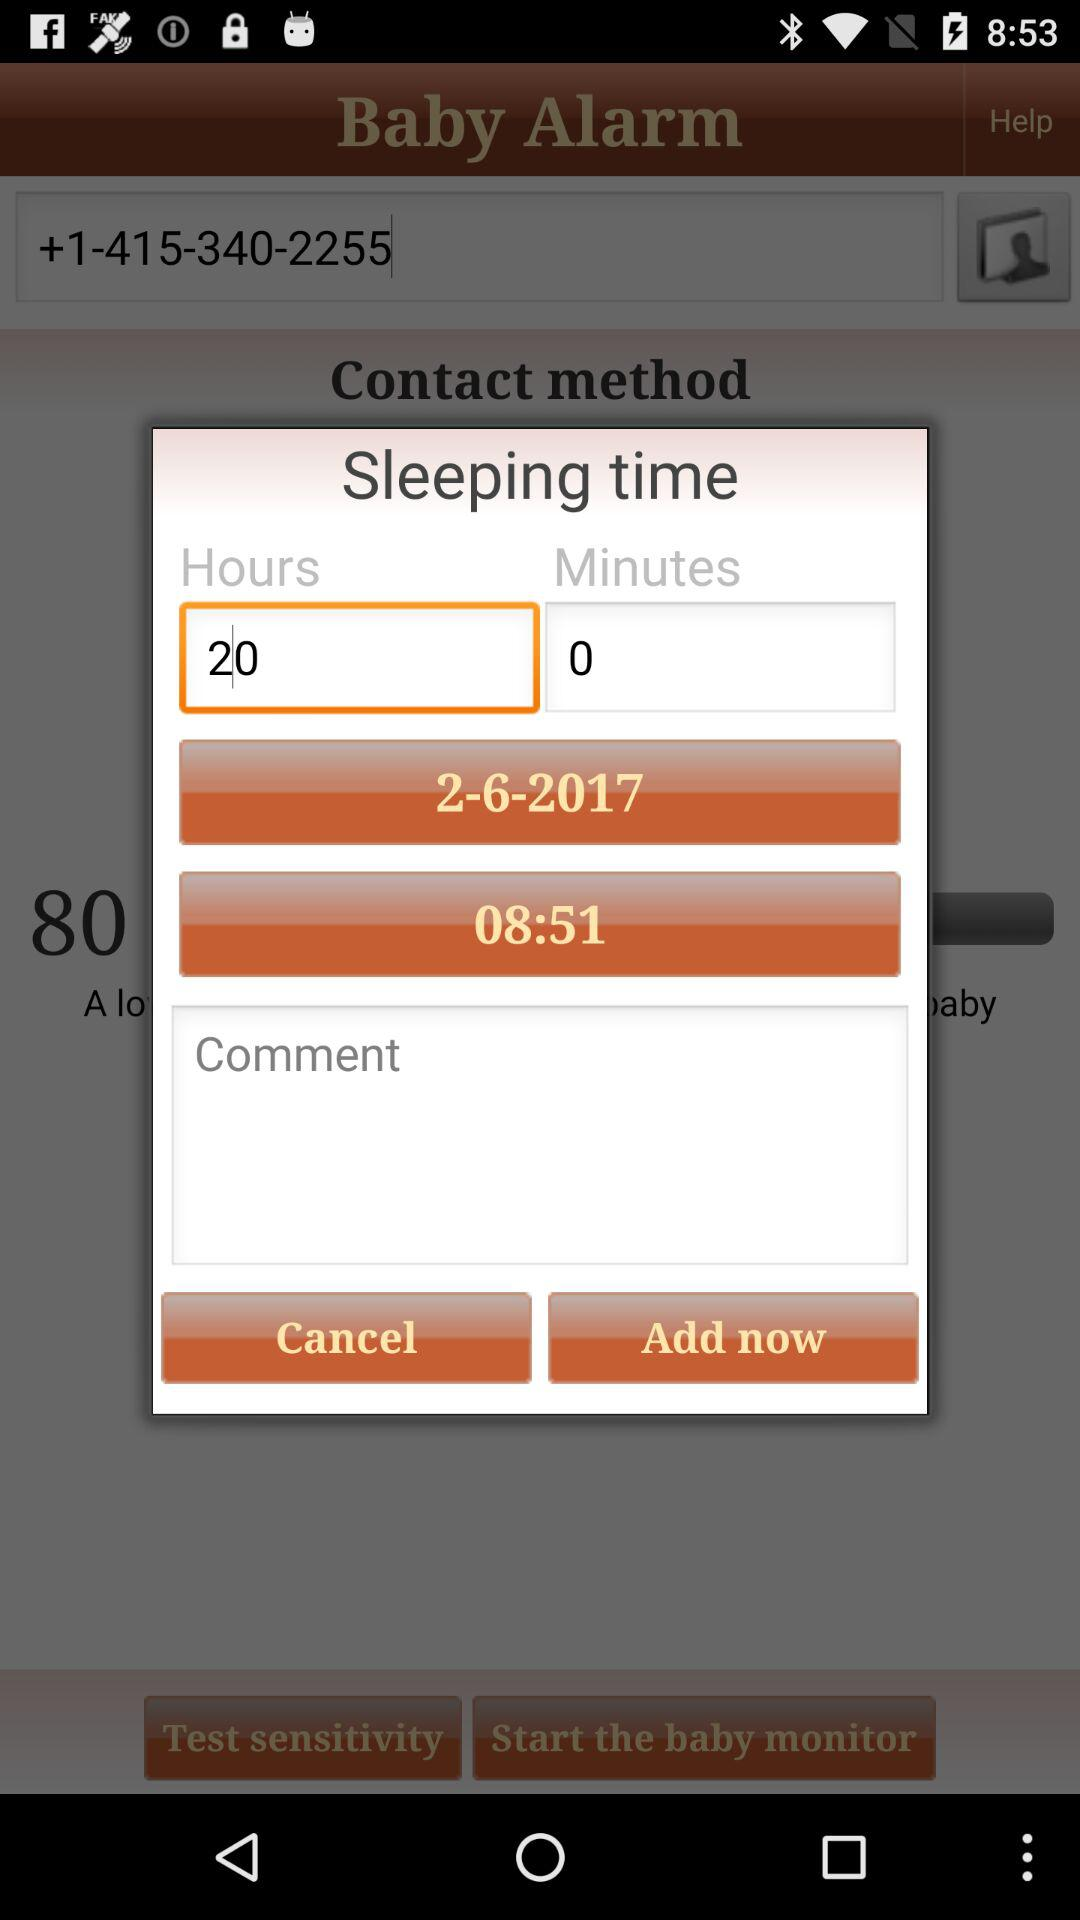How many hours are there? There are 20 hours. 